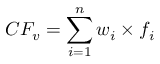<formula> <loc_0><loc_0><loc_500><loc_500>C F _ { v } = \sum _ { i = 1 } ^ { n } w _ { i } \times f _ { i }</formula> 